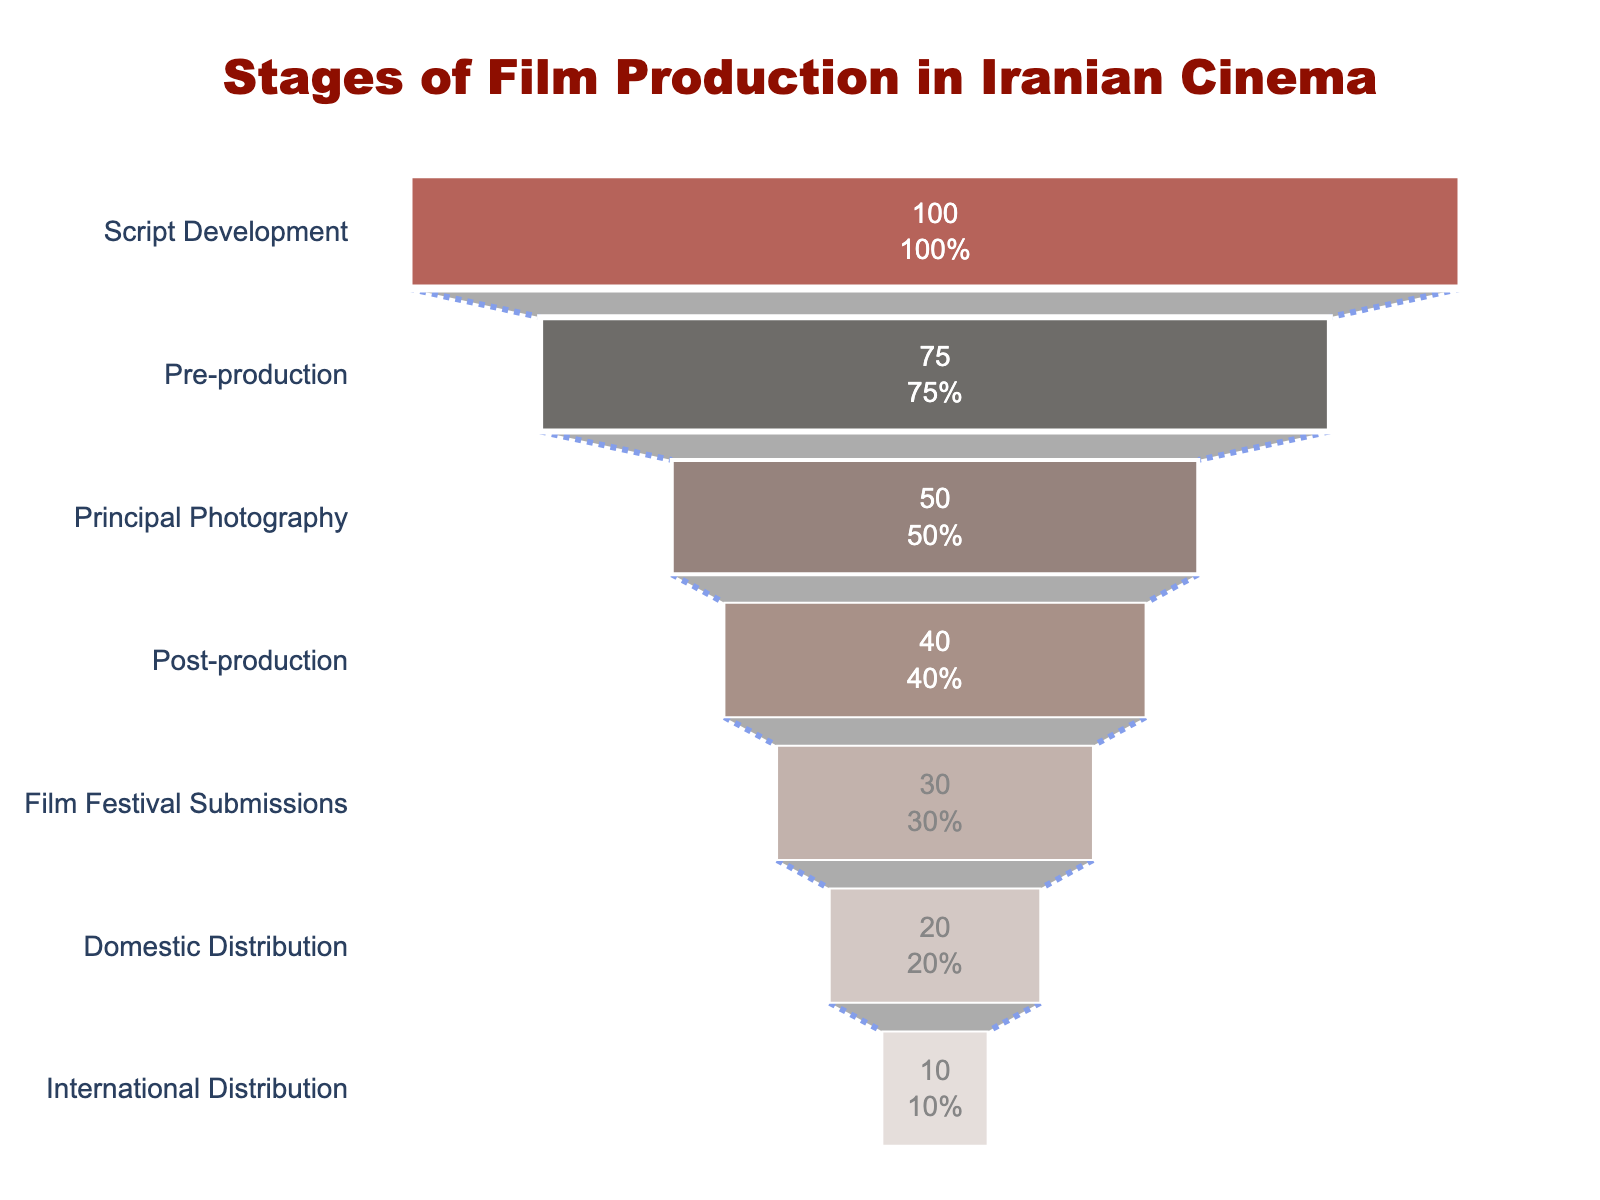What is the title of the chart? The title is located at the top of the chart. It provides a clear description of what the chart represents.
Answer: Stages of Film Production in Iranian Cinema How many stages of film production are represented in the funnel chart? Count the number of distinct stages listed on the funnel chart.
Answer: 7 Which stage has the highest number of projects? Identify the stage at the widest part of the funnel chart.
Answer: Script Development What percentage of projects move from Script Development to Pre-production? Calculate the percentage of projects in Pre-production relative to Script Development (75/100 * 100%).
Answer: 75% How many fewer projects are there in Post-production compared to Principal Photography? Subtract the number of projects in Post-production from the number of projects in Principal Photography (50 - 40).
Answer: 10 What is the difference in the number of projects between Domestic and International Distribution? Subtract the number of projects in International Distribution from Domestic Distribution (20 - 10).
Answer: 10 How many more projects are there in Script Development compared to Domestic Distribution? Subtract the number of projects in Domestic Distribution from the number of projects in Script Development (100 - 20).
Answer: 80 Which stage has half the number of projects compared to Film Festival Submissions? Identify the stage with half the number of projects in Film Festival Submissions (30 / 2 = 15). Since no stage has exactly 15 projects, recognize that one closest might be International Distribution.
Answer: International Distribution What percentage of all projects reach International Distribution? Calculate the percentage of projects in International Distribution relative to the initial number of projects in Script Development (10/100 * 100%).
Answer: 10% How many stages have fewer than 50 projects? Count the number of stages in the chart with a number of projects below 50.
Answer: 4 